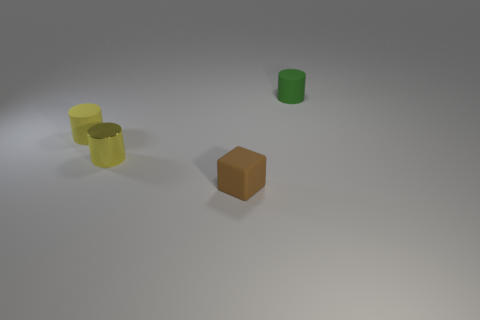What number of large purple matte balls are there?
Give a very brief answer. 0. There is a yellow thing that is made of the same material as the green cylinder; what is its shape?
Your response must be concise. Cylinder. There is a brown rubber object right of the tiny matte cylinder that is to the left of the small green rubber thing; how big is it?
Offer a terse response. Small. How many things are either rubber things that are on the left side of the small brown object or things on the left side of the green matte cylinder?
Your answer should be very brief. 3. Are there fewer green rubber things than tiny shiny blocks?
Make the answer very short. No. What number of objects are blue cylinders or yellow metal cylinders?
Your response must be concise. 1. Do the small green thing and the metal thing have the same shape?
Offer a terse response. Yes. Are there any other things that are made of the same material as the block?
Provide a short and direct response. Yes. Is the size of the green cylinder that is on the right side of the tiny yellow shiny cylinder the same as the yellow cylinder that is in front of the small yellow rubber cylinder?
Give a very brief answer. Yes. There is a small cylinder that is both right of the yellow rubber object and in front of the small green thing; what material is it?
Provide a short and direct response. Metal. 